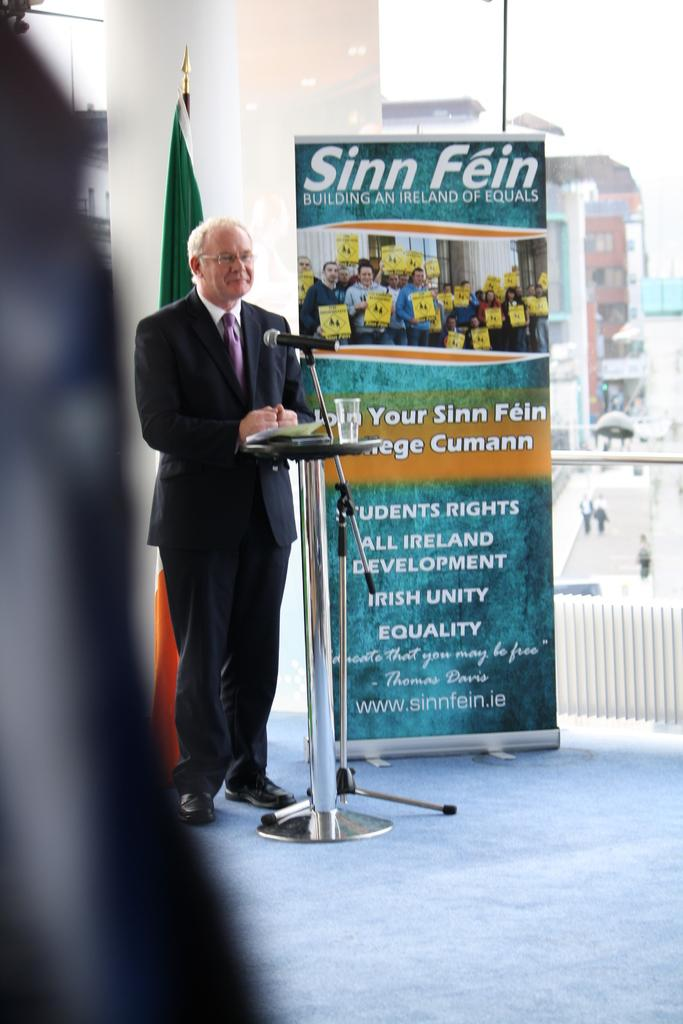What is the person in the image doing? The person is standing in front of a mic. What can be seen besides the person in the image? There is a flag and a poster with text in the image. What is visible in the background of the image? There are buildings visible in the background of the image. What reason does the visitor have for offering the poster in the image? There is no visitor present in the image, and therefore no reason or offer can be attributed to them. 